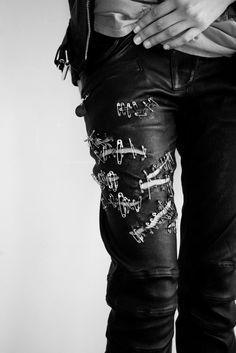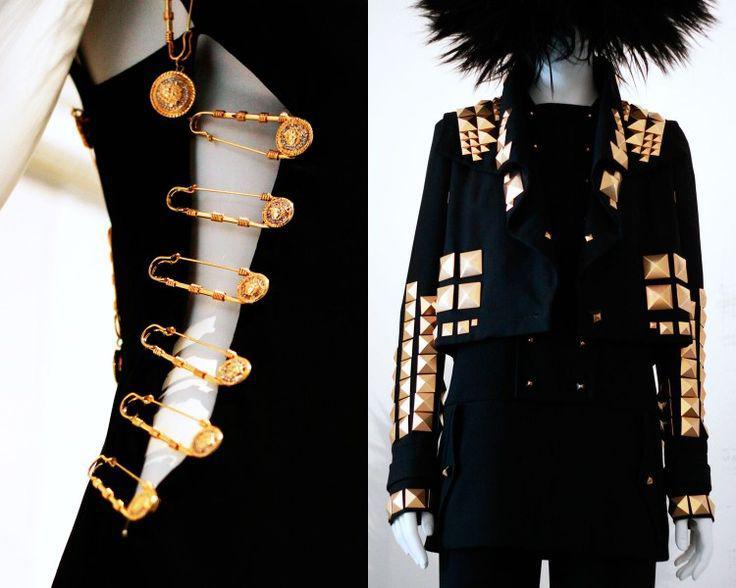The first image is the image on the left, the second image is the image on the right. For the images shown, is this caption "someone is wearing a pair of pants full of safety pins and a pair of heels" true? Answer yes or no. No. The first image is the image on the left, the second image is the image on the right. Examine the images to the left and right. Is the description "One of the images shows high heeled platform shoes." accurate? Answer yes or no. No. 